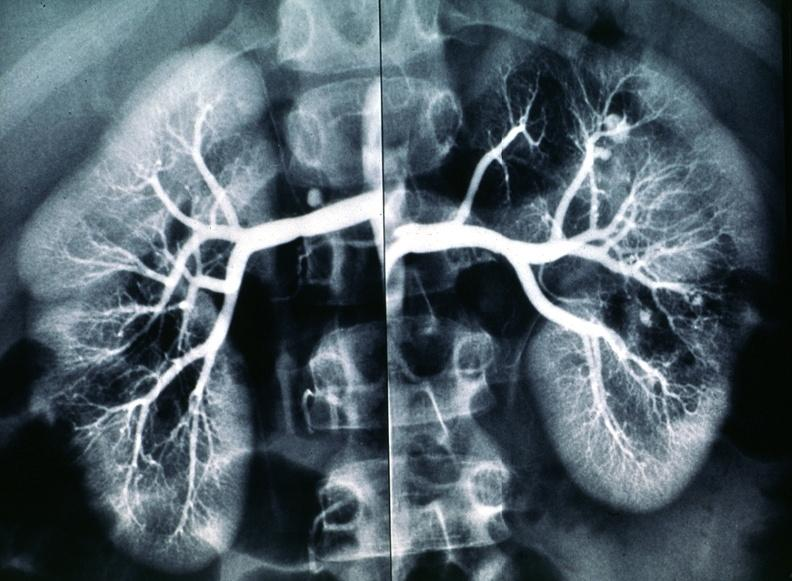does metastatic carcinoma lung show polyarteritis nodosa, kidney arteriogram?
Answer the question using a single word or phrase. No 